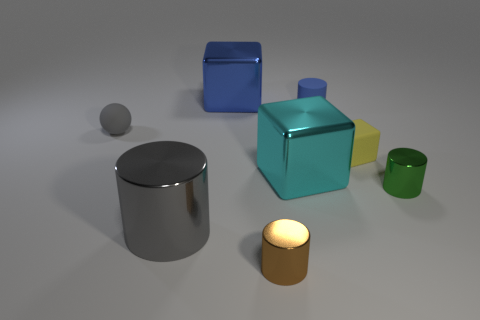Is there any other thing that has the same color as the small matte cylinder?
Your answer should be very brief. Yes. Do the ball and the big metal cylinder have the same color?
Your answer should be compact. Yes. There is a large block that is behind the cyan metal object; is its color the same as the small rubber cylinder?
Offer a very short reply. Yes. There is a tiny cylinder behind the green metal object; are there any small blue cylinders that are left of it?
Provide a succinct answer. No. Are the object that is to the left of the large cylinder and the small yellow object made of the same material?
Give a very brief answer. Yes. How many metal objects are behind the rubber cylinder and in front of the large cyan cube?
Keep it short and to the point. 0. What number of small green objects are the same material as the large cyan thing?
Give a very brief answer. 1. There is a large cylinder that is the same material as the brown object; what is its color?
Make the answer very short. Gray. Are there fewer tiny rubber things than gray shiny objects?
Your answer should be compact. No. There is a tiny gray ball that is left of the metal block that is behind the small rubber object on the left side of the gray shiny cylinder; what is it made of?
Your answer should be compact. Rubber. 